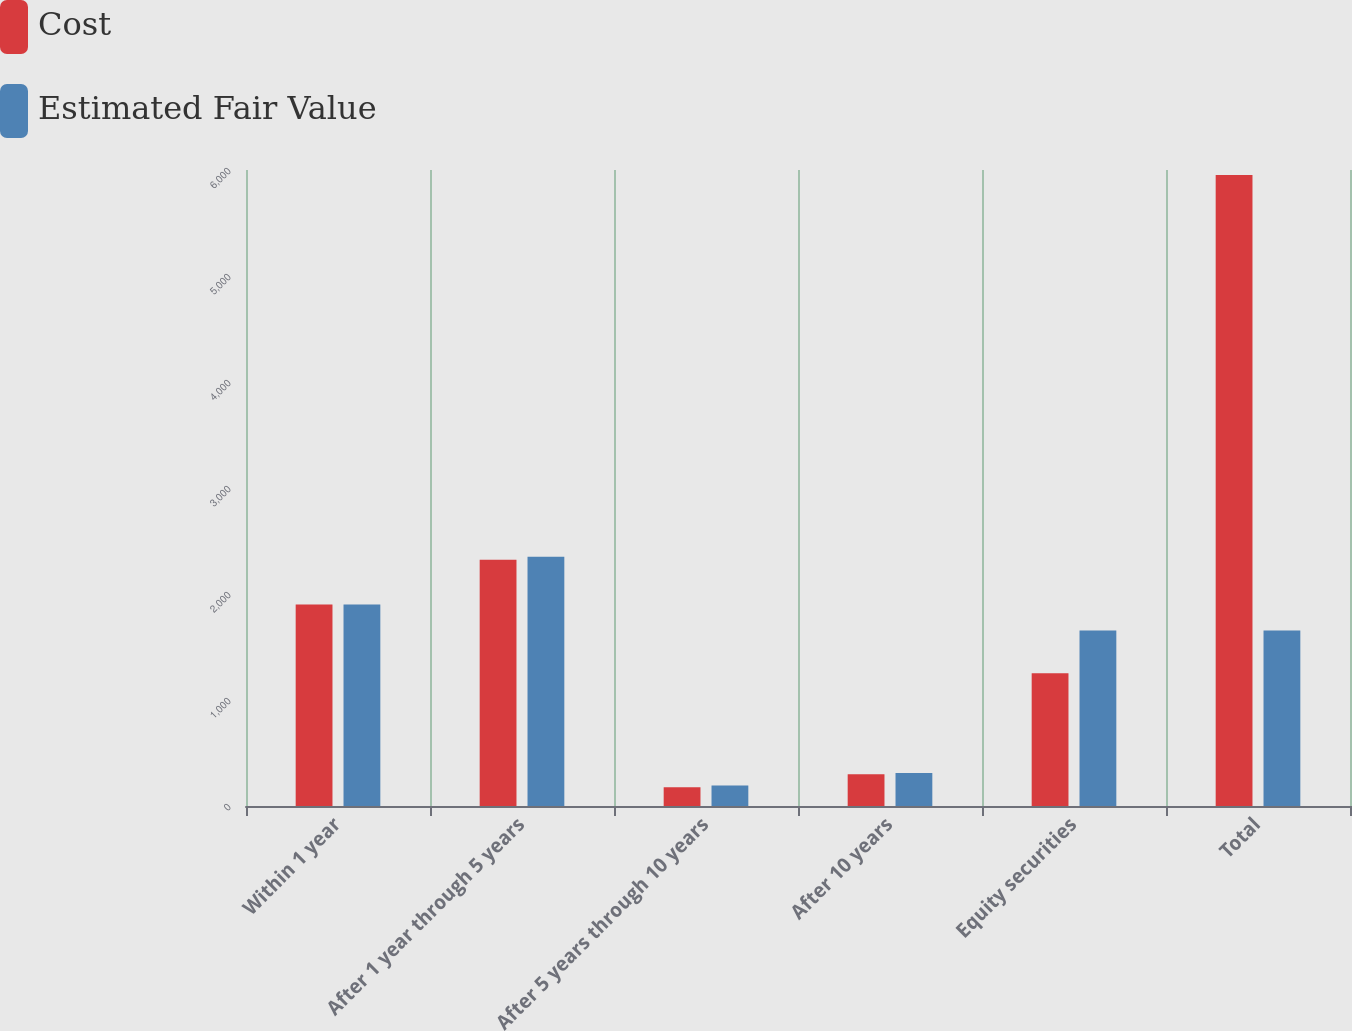Convert chart to OTSL. <chart><loc_0><loc_0><loc_500><loc_500><stacked_bar_chart><ecel><fcel>Within 1 year<fcel>After 1 year through 5 years<fcel>After 5 years through 10 years<fcel>After 10 years<fcel>Equity securities<fcel>Total<nl><fcel>Cost<fcel>1900<fcel>2324<fcel>176<fcel>300<fcel>1252<fcel>5952<nl><fcel>Estimated Fair Value<fcel>1900<fcel>2352<fcel>194<fcel>312<fcel>1655<fcel>1655<nl></chart> 